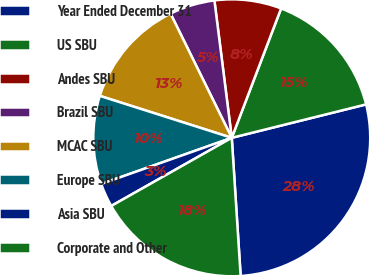<chart> <loc_0><loc_0><loc_500><loc_500><pie_chart><fcel>Year Ended December 31<fcel>US SBU<fcel>Andes SBU<fcel>Brazil SBU<fcel>MCAC SBU<fcel>Europe SBU<fcel>Asia SBU<fcel>Corporate and Other<nl><fcel>27.86%<fcel>15.32%<fcel>7.8%<fcel>5.29%<fcel>12.81%<fcel>10.31%<fcel>2.78%<fcel>17.83%<nl></chart> 